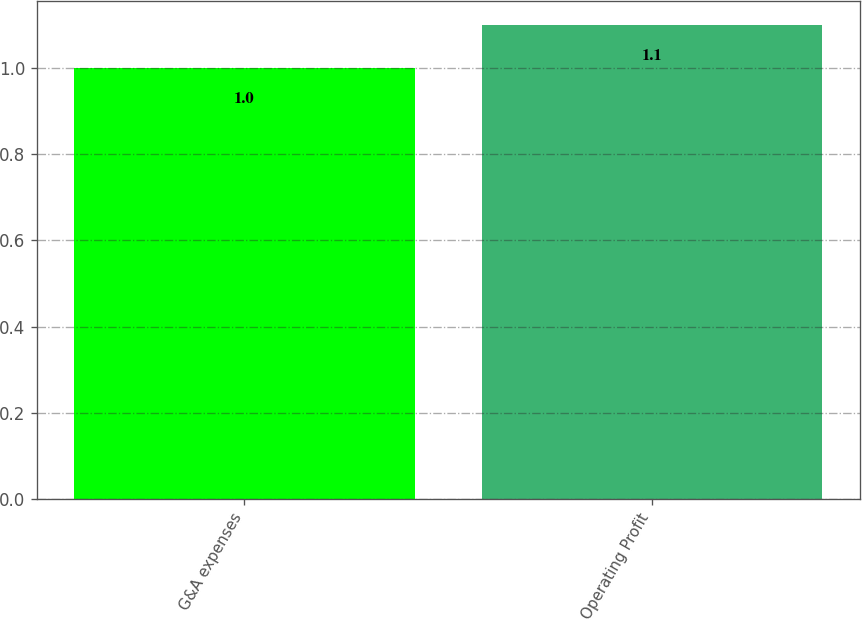<chart> <loc_0><loc_0><loc_500><loc_500><bar_chart><fcel>G&A expenses<fcel>Operating Profit<nl><fcel>1<fcel>1.1<nl></chart> 